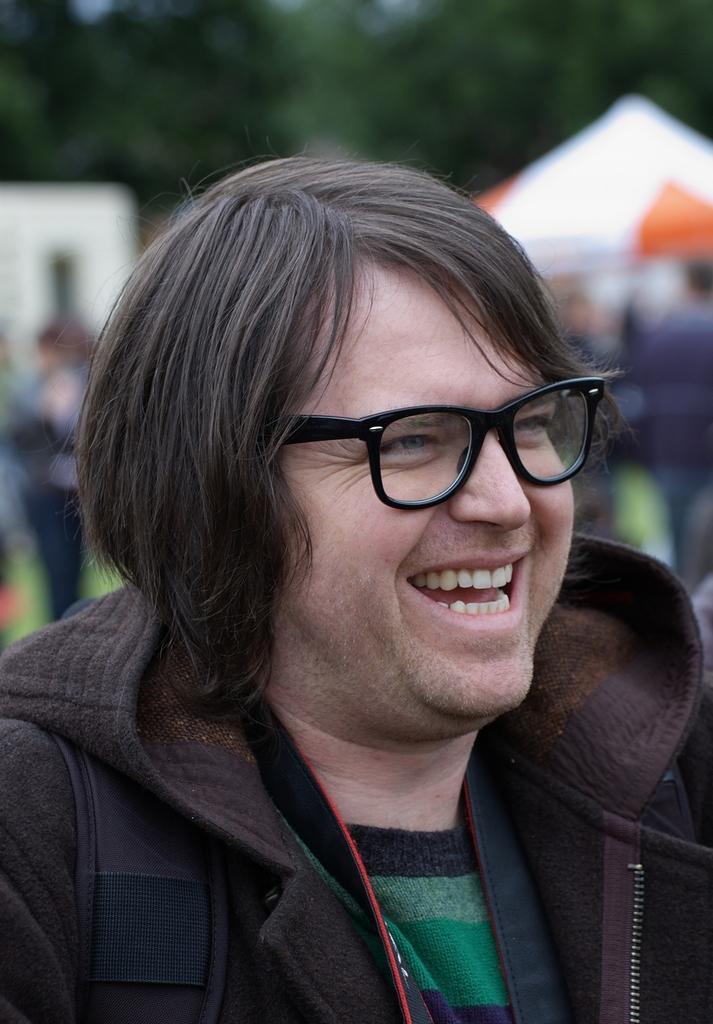In one or two sentences, can you explain what this image depicts? In this image we can see a person wearing glasses and we can also see a blurred background. 